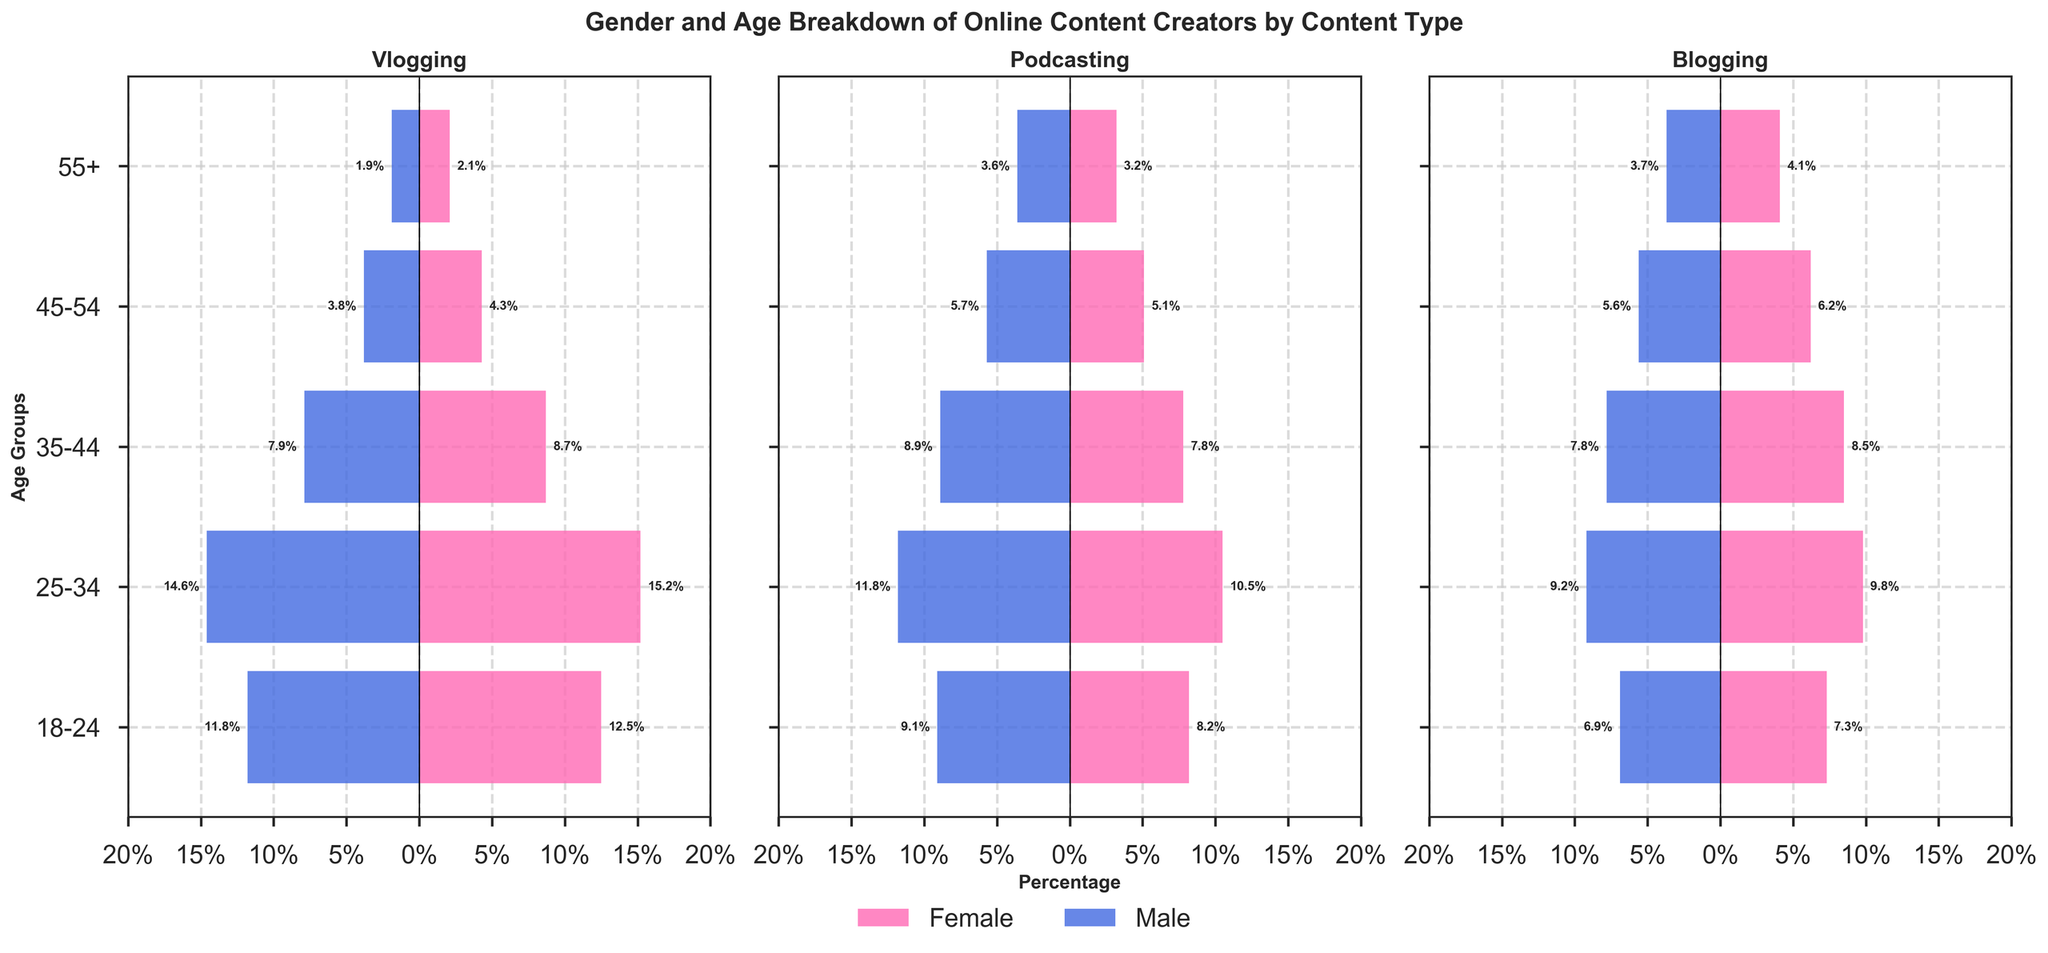What is the total percentage of female vloggers in the 25-34 age group? To find the total percentage of female vloggers in the 25-34 age group, refer to the data under the vlogging section for females aged 25-34.
Answer: 15.2% Which age group has the highest percentage of male podcasters? Compare the percentages of male podcasters across different age groups and identify the highest value.
Answer: 25-34 How does the percentage of female bloggers in the 55+ age group compare to the percentage of male bloggers in the same age group? Compare the values of female and male bloggers in the 55+ age group to see which one is higher.
Answer: Female bloggers are higher (4.1% vs 3.7%) Which content type has the largest gender disparity in the 18-24 age group? Compute the absolute difference between the percentages of males and females for each content type in the 18-24 age group, and identify the content type with the largest difference.
Answer: Vlogging What is the combined percentage of female and male vloggers in the 35-44 age group? Sum the percentages of both female and male vloggers in the 35-44 age group. Female: 8.7%, Male: 7.9%. Sum: 8.7 + 7.9.
Answer: 16.6% Do male or female podcasters in the 45-54 age group represent a higher percentage? Compare the percentage values of male and female podcasters in the 45-54 age group and see which one is higher.
Answer: Male (5.7% vs 5.1%) What percentage of the overall blogging content creators is 18-24 years old? Add the percentages of both male and female bloggers who are 18-24 years old. Female: 7.3%, Male: 6.9%. Sum: 7.3 + 6.9.
Answer: 14.2% In the 25-34 age group, which content type has the highest percentage of female content creators? Compare the percentages of female content creators aged 25-34 across different content types and identify the highest value.
Answer: Vlogging (15.2%) What is the total percentage of male content creators in the 55+ age group across all content types? Sum the percentages of male content creators in the 55+ age group for all content types. Vlogging: 1.9%, Podcasting: 3.6%, Blogging: 3.7%. Sum: 1.9 + 3.6 + 3.7.
Answer: 9.2% Overall, which gender has a higher percentage of content creators in the 18-24 age group? Sum the percentages of all female and male content creators in the 18-24 age group for all content types and compare the totals. Female: Vlogging (12.5%) + Podcasting (8.2%) + Blogging (7.3%) = 28.0%. Male: Vlogging (11.8%) + Podcasting (9.1%) + Blogging (6.9%) = 27.8%.
Answer: Female 